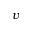<formula> <loc_0><loc_0><loc_500><loc_500>v</formula> 